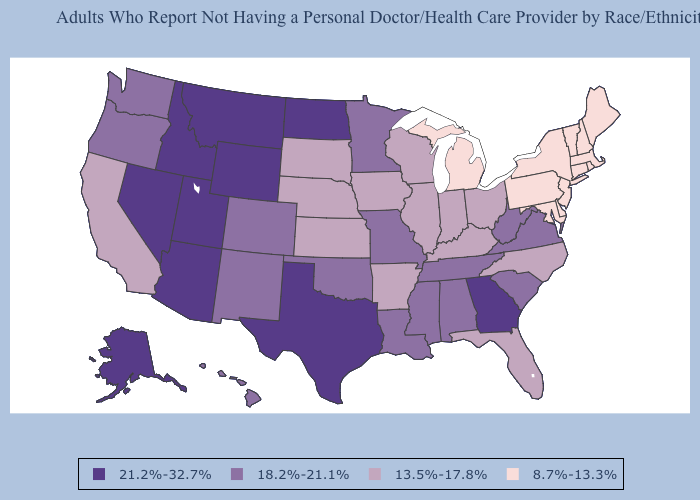What is the lowest value in states that border Wisconsin?
Give a very brief answer. 8.7%-13.3%. What is the highest value in the MidWest ?
Keep it brief. 21.2%-32.7%. How many symbols are there in the legend?
Short answer required. 4. Does Mississippi have the lowest value in the USA?
Give a very brief answer. No. What is the highest value in the West ?
Concise answer only. 21.2%-32.7%. Which states have the lowest value in the USA?
Give a very brief answer. Connecticut, Delaware, Maine, Maryland, Massachusetts, Michigan, New Hampshire, New Jersey, New York, Pennsylvania, Rhode Island, Vermont. Among the states that border California , does Oregon have the highest value?
Give a very brief answer. No. What is the value of South Dakota?
Keep it brief. 13.5%-17.8%. Name the states that have a value in the range 18.2%-21.1%?
Give a very brief answer. Alabama, Colorado, Hawaii, Louisiana, Minnesota, Mississippi, Missouri, New Mexico, Oklahoma, Oregon, South Carolina, Tennessee, Virginia, Washington, West Virginia. Which states hav the highest value in the West?
Short answer required. Alaska, Arizona, Idaho, Montana, Nevada, Utah, Wyoming. Does the first symbol in the legend represent the smallest category?
Quick response, please. No. What is the value of New Jersey?
Quick response, please. 8.7%-13.3%. Name the states that have a value in the range 8.7%-13.3%?
Concise answer only. Connecticut, Delaware, Maine, Maryland, Massachusetts, Michigan, New Hampshire, New Jersey, New York, Pennsylvania, Rhode Island, Vermont. Name the states that have a value in the range 13.5%-17.8%?
Be succinct. Arkansas, California, Florida, Illinois, Indiana, Iowa, Kansas, Kentucky, Nebraska, North Carolina, Ohio, South Dakota, Wisconsin. What is the highest value in the USA?
Answer briefly. 21.2%-32.7%. 